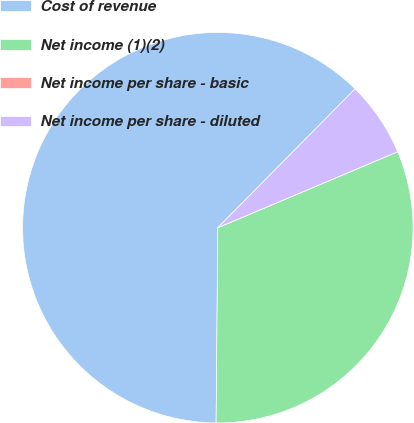<chart> <loc_0><loc_0><loc_500><loc_500><pie_chart><fcel>Cost of revenue<fcel>Net income (1)(2)<fcel>Net income per share - basic<fcel>Net income per share - diluted<nl><fcel>62.27%<fcel>31.5%<fcel>0.0%<fcel>6.23%<nl></chart> 